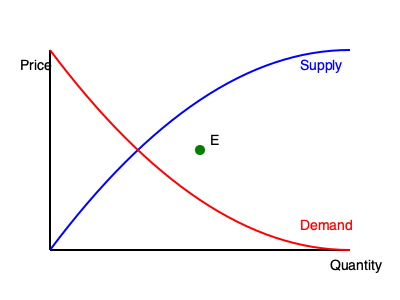In the given supply and demand graph, what would be the effect on the equilibrium price and quantity if the government imposes a price ceiling below the current equilibrium point E? To answer this question, let's analyze the effects of a price ceiling step-by-step:

1. The current equilibrium point E represents the free market equilibrium where supply equals demand.

2. A price ceiling is a maximum price set by the government, which in this case is below the equilibrium price.

3. When the price ceiling is imposed:
   a) The market price will be forced down to the ceiling price.
   b) At this lower price, suppliers are willing to produce less quantity (move left on the supply curve).
   c) At the same lower price, consumers demand more quantity (move right on the demand curve).

4. This creates a situation where:
   a) Quantity supplied < Quantity demanded
   b) A shortage occurs in the market

5. Effects on equilibrium:
   a) Price: Decreases from the free market equilibrium to the price ceiling
   b) Quantity: Decreases from the free market equilibrium to the quantity suppliers are willing to produce at the ceiling price

6. Additional consequences:
   a) Black markets may emerge
   b) Non-price rationing methods might be implemented (e.g., queues, rations)

In a free market perspective, this intervention distorts market signals and leads to inefficient allocation of resources.
Answer: Decreased price and quantity, creating shortage 